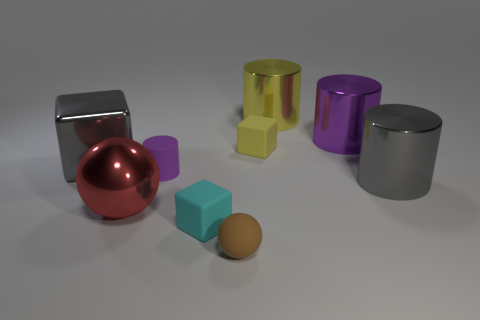Subtract all metal cylinders. How many cylinders are left? 1 Subtract all yellow cylinders. How many cylinders are left? 3 Subtract all cyan cylinders. Subtract all gray spheres. How many cylinders are left? 4 Subtract all spheres. How many objects are left? 7 Add 5 gray shiny cubes. How many gray shiny cubes exist? 6 Subtract 0 red cylinders. How many objects are left? 9 Subtract all gray shiny blocks. Subtract all tiny purple cylinders. How many objects are left? 7 Add 7 red metal objects. How many red metal objects are left? 8 